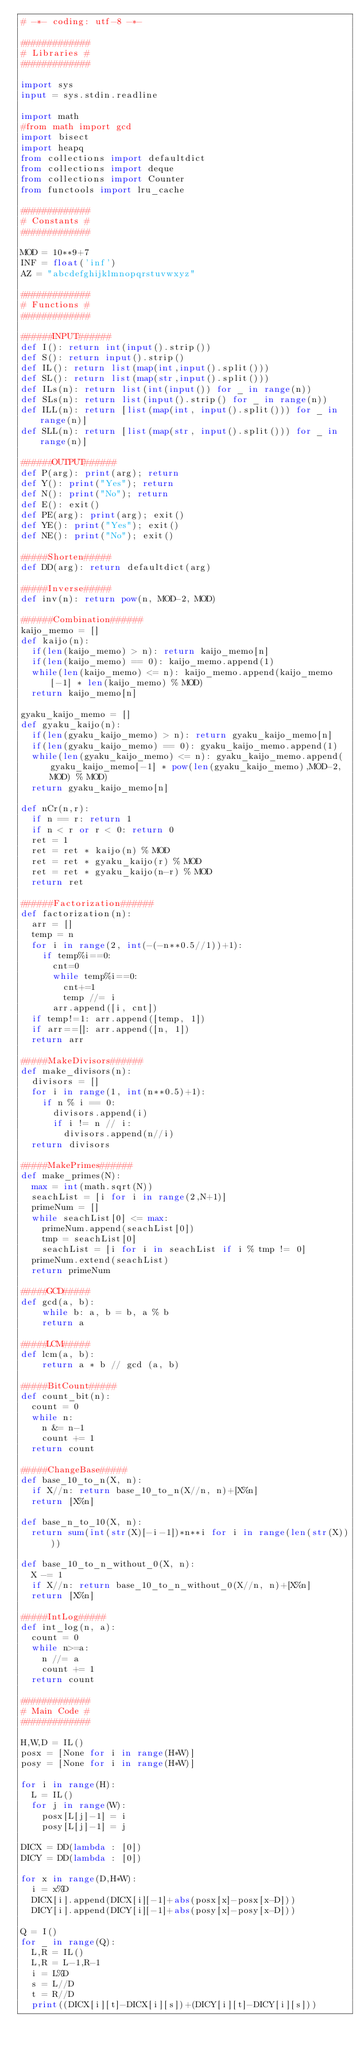Convert code to text. <code><loc_0><loc_0><loc_500><loc_500><_Python_># -*- coding: utf-8 -*-

#############
# Libraries #
#############

import sys
input = sys.stdin.readline

import math
#from math import gcd
import bisect
import heapq
from collections import defaultdict
from collections import deque
from collections import Counter
from functools import lru_cache

#############
# Constants #
#############

MOD = 10**9+7
INF = float('inf')
AZ = "abcdefghijklmnopqrstuvwxyz"

#############
# Functions #
#############

######INPUT######
def I(): return int(input().strip())
def S(): return input().strip()
def IL(): return list(map(int,input().split()))
def SL(): return list(map(str,input().split()))
def ILs(n): return list(int(input()) for _ in range(n))
def SLs(n): return list(input().strip() for _ in range(n))
def ILL(n): return [list(map(int, input().split())) for _ in range(n)]
def SLL(n): return [list(map(str, input().split())) for _ in range(n)]

######OUTPUT######
def P(arg): print(arg); return
def Y(): print("Yes"); return
def N(): print("No"); return
def E(): exit()
def PE(arg): print(arg); exit()
def YE(): print("Yes"); exit()
def NE(): print("No"); exit()

#####Shorten#####
def DD(arg): return defaultdict(arg)

#####Inverse#####
def inv(n): return pow(n, MOD-2, MOD)

######Combination######
kaijo_memo = []
def kaijo(n):
  if(len(kaijo_memo) > n): return kaijo_memo[n]
  if(len(kaijo_memo) == 0): kaijo_memo.append(1)
  while(len(kaijo_memo) <= n): kaijo_memo.append(kaijo_memo[-1] * len(kaijo_memo) % MOD)
  return kaijo_memo[n]

gyaku_kaijo_memo = []
def gyaku_kaijo(n):
  if(len(gyaku_kaijo_memo) > n): return gyaku_kaijo_memo[n]
  if(len(gyaku_kaijo_memo) == 0): gyaku_kaijo_memo.append(1)
  while(len(gyaku_kaijo_memo) <= n): gyaku_kaijo_memo.append(gyaku_kaijo_memo[-1] * pow(len(gyaku_kaijo_memo),MOD-2,MOD) % MOD)
  return gyaku_kaijo_memo[n]

def nCr(n,r):
  if n == r: return 1
  if n < r or r < 0: return 0
  ret = 1
  ret = ret * kaijo(n) % MOD
  ret = ret * gyaku_kaijo(r) % MOD
  ret = ret * gyaku_kaijo(n-r) % MOD
  return ret

######Factorization######
def factorization(n):
  arr = []
  temp = n
  for i in range(2, int(-(-n**0.5//1))+1):
    if temp%i==0:
      cnt=0
      while temp%i==0: 
        cnt+=1 
        temp //= i
      arr.append([i, cnt])
  if temp!=1: arr.append([temp, 1])
  if arr==[]: arr.append([n, 1])
  return arr

#####MakeDivisors######
def make_divisors(n):
  divisors = []
  for i in range(1, int(n**0.5)+1):
    if n % i == 0:
      divisors.append(i)
      if i != n // i: 
        divisors.append(n//i)
  return divisors

#####MakePrimes######
def make_primes(N):
  max = int(math.sqrt(N))
  seachList = [i for i in range(2,N+1)]
  primeNum = []
  while seachList[0] <= max:
    primeNum.append(seachList[0])
    tmp = seachList[0]
    seachList = [i for i in seachList if i % tmp != 0]
  primeNum.extend(seachList)
  return primeNum

#####GCD#####
def gcd(a, b):
    while b: a, b = b, a % b
    return a

#####LCM#####
def lcm(a, b):
    return a * b // gcd (a, b)

#####BitCount#####
def count_bit(n):
  count = 0
  while n:
    n &= n-1
    count += 1
  return count

#####ChangeBase#####
def base_10_to_n(X, n):
  if X//n: return base_10_to_n(X//n, n)+[X%n]
  return [X%n]

def base_n_to_10(X, n):
  return sum(int(str(X)[-i-1])*n**i for i in range(len(str(X))))

def base_10_to_n_without_0(X, n):
  X -= 1
  if X//n: return base_10_to_n_without_0(X//n, n)+[X%n]
  return [X%n]

#####IntLog#####
def int_log(n, a):
  count = 0
  while n>=a:
    n //= a
    count += 1
  return count

#############
# Main Code #
#############

H,W,D = IL()
posx = [None for i in range(H*W)]
posy = [None for i in range(H*W)]

for i in range(H):
  L = IL()
  for j in range(W):
    posx[L[j]-1] = i
    posy[L[j]-1] = j
    
DICX = DD(lambda : [0])
DICY = DD(lambda : [0])

for x in range(D,H*W):
  i = x%D
  DICX[i].append(DICX[i][-1]+abs(posx[x]-posx[x-D]))
  DICY[i].append(DICY[i][-1]+abs(posy[x]-posy[x-D]))

Q = I()
for _ in range(Q):
  L,R = IL()
  L,R = L-1,R-1
  i = L%D
  s = L//D
  t = R//D
  print((DICX[i][t]-DICX[i][s])+(DICY[i][t]-DICY[i][s]))</code> 